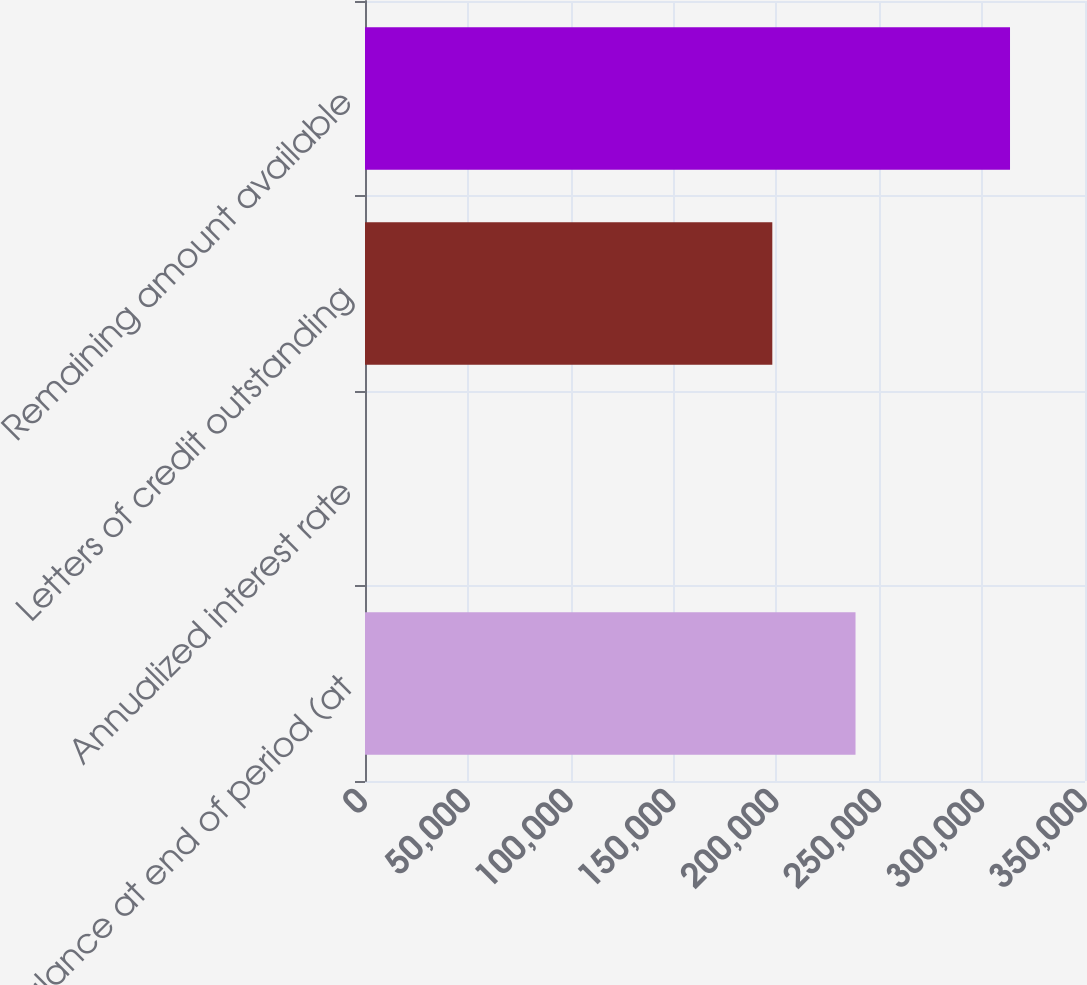Convert chart to OTSL. <chart><loc_0><loc_0><loc_500><loc_500><bar_chart><fcel>Balance at end of period (at<fcel>Annualized interest rate<fcel>Letters of credit outstanding<fcel>Remaining amount available<nl><fcel>238450<fcel>0.32<fcel>198000<fcel>313550<nl></chart> 